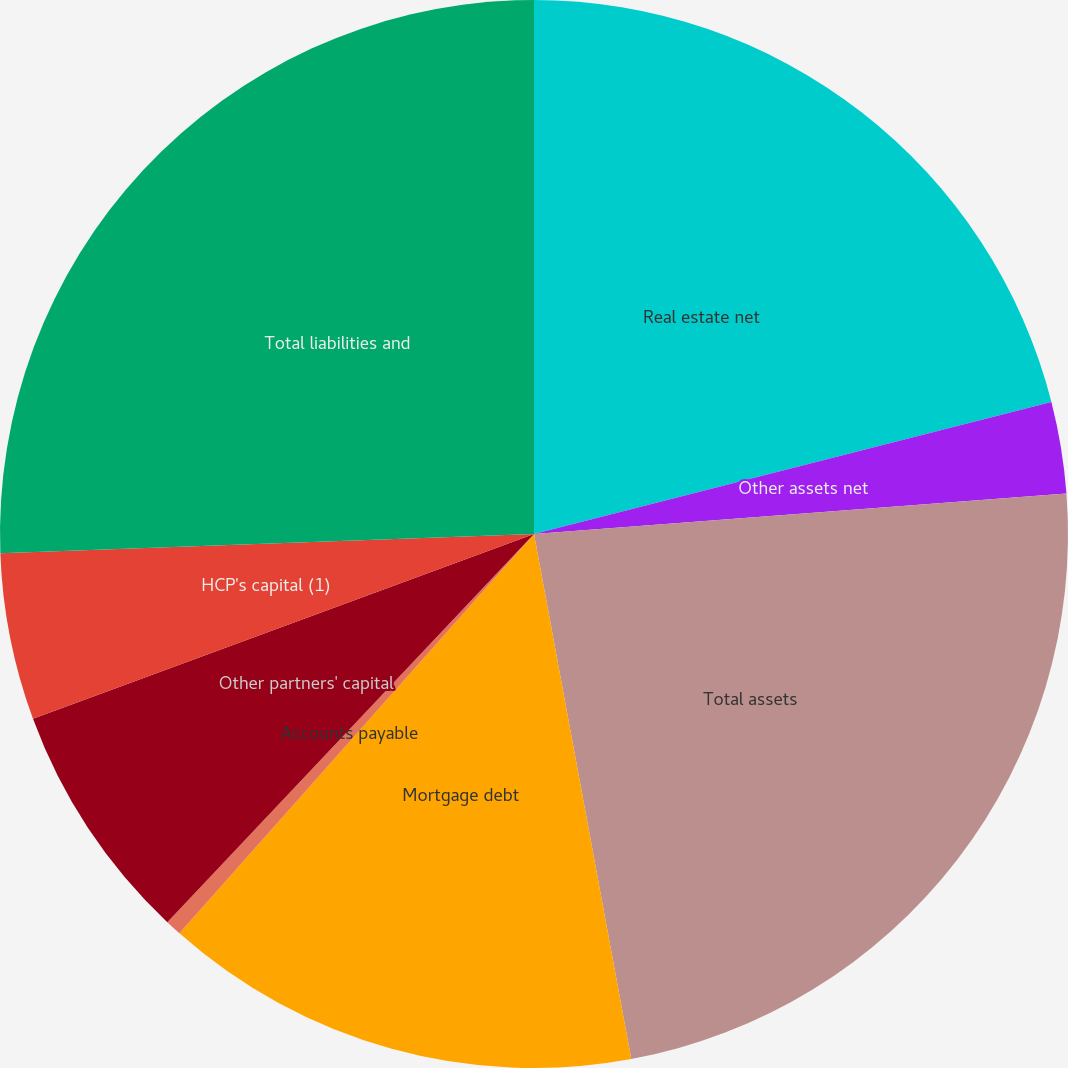Convert chart. <chart><loc_0><loc_0><loc_500><loc_500><pie_chart><fcel>Real estate net<fcel>Other assets net<fcel>Total assets<fcel>Mortgage debt<fcel>Accounts payable<fcel>Other partners' capital<fcel>HCP's capital (1)<fcel>Total liabilities and<nl><fcel>21.02%<fcel>2.77%<fcel>23.29%<fcel>14.47%<fcel>0.49%<fcel>7.33%<fcel>5.05%<fcel>25.57%<nl></chart> 